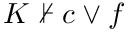<formula> <loc_0><loc_0><loc_500><loc_500>K \not \vdash c \vee f</formula> 